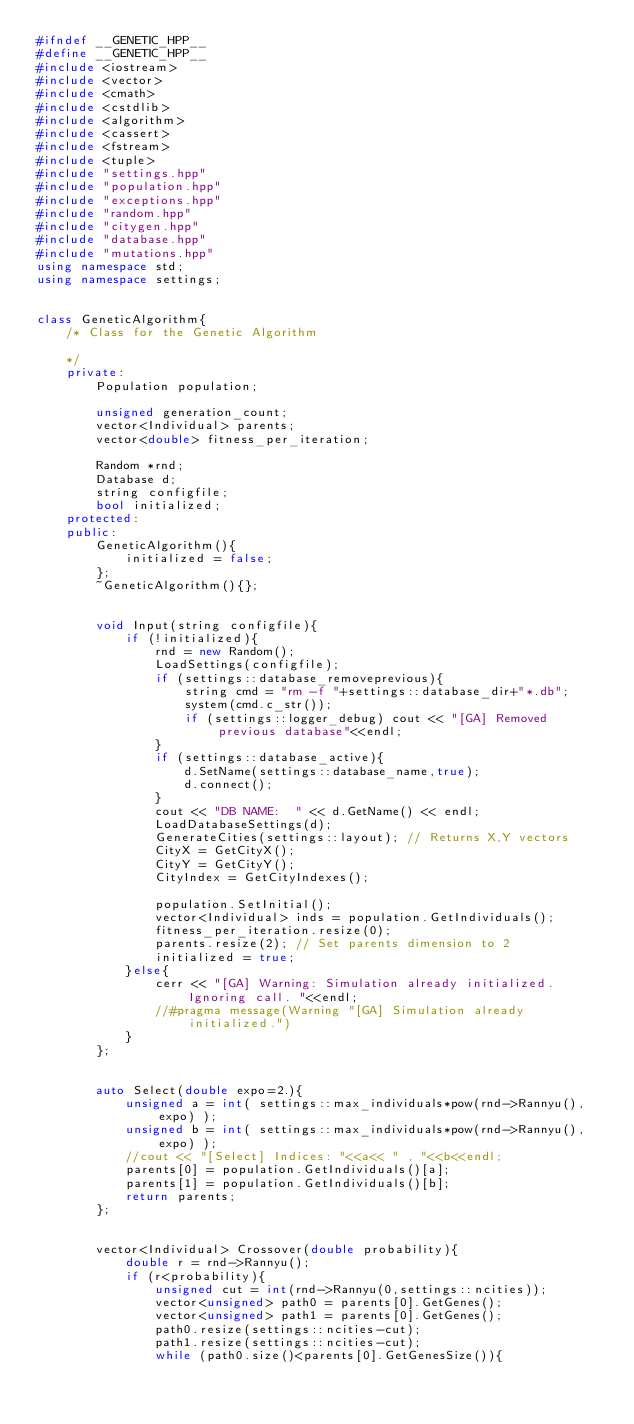<code> <loc_0><loc_0><loc_500><loc_500><_C++_>#ifndef __GENETIC_HPP__
#define __GENETIC_HPP__
#include <iostream>
#include <vector>
#include <cmath>
#include <cstdlib>
#include <algorithm>
#include <cassert>
#include <fstream>
#include <tuple>
#include "settings.hpp"
#include "population.hpp"
#include "exceptions.hpp"
#include "random.hpp"
#include "citygen.hpp"
#include "database.hpp"
#include "mutations.hpp"
using namespace std;
using namespace settings;


class GeneticAlgorithm{
    /* Class for the Genetic Algorithm

    */
    private:
        Population population;
        
        unsigned generation_count;
        vector<Individual> parents;
        vector<double> fitness_per_iteration;

        Random *rnd;
        Database d;
        string configfile;
        bool initialized;
    protected:
    public:
        GeneticAlgorithm(){
            initialized = false;
        };
        ~GeneticAlgorithm(){};


        void Input(string configfile){
            if (!initialized){ 
                rnd = new Random();
                LoadSettings(configfile);
                if (settings::database_removeprevious){
                    string cmd = "rm -f "+settings::database_dir+"*.db";
                    system(cmd.c_str());
                    if (settings::logger_debug) cout << "[GA] Removed previous database"<<endl;
                }
                if (settings::database_active){
                    d.SetName(settings::database_name,true);
                    d.connect();
                }
                cout << "DB NAME:  " << d.GetName() << endl;
                LoadDatabaseSettings(d);
                GenerateCities(settings::layout); // Returns X,Y vectors
                CityX = GetCityX();
                CityY = GetCityY();
                CityIndex = GetCityIndexes();

                population.SetInitial();
                vector<Individual> inds = population.GetIndividuals();
                fitness_per_iteration.resize(0);
                parents.resize(2); // Set parents dimension to 2
                initialized = true;
            }else{
                cerr << "[GA] Warning: Simulation already initialized. Ignoring call. "<<endl;
                //#pragma message(Warning "[GA] Simulation already initialized.")
            }
        };


        auto Select(double expo=2.){
            unsigned a = int( settings::max_individuals*pow(rnd->Rannyu(),expo) );
            unsigned b = int( settings::max_individuals*pow(rnd->Rannyu(),expo) );
            //cout << "[Select] Indices: "<<a<< " , "<<b<<endl;
            parents[0] = population.GetIndividuals()[a];
            parents[1] = population.GetIndividuals()[b];
            return parents;
        };


        vector<Individual> Crossover(double probability){
            double r = rnd->Rannyu();
            if (r<probability){
                unsigned cut = int(rnd->Rannyu(0,settings::ncities));
                vector<unsigned> path0 = parents[0].GetGenes();
                vector<unsigned> path1 = parents[0].GetGenes();
                path0.resize(settings::ncities-cut);
                path1.resize(settings::ncities-cut);
                while (path0.size()<parents[0].GetGenesSize()){</code> 